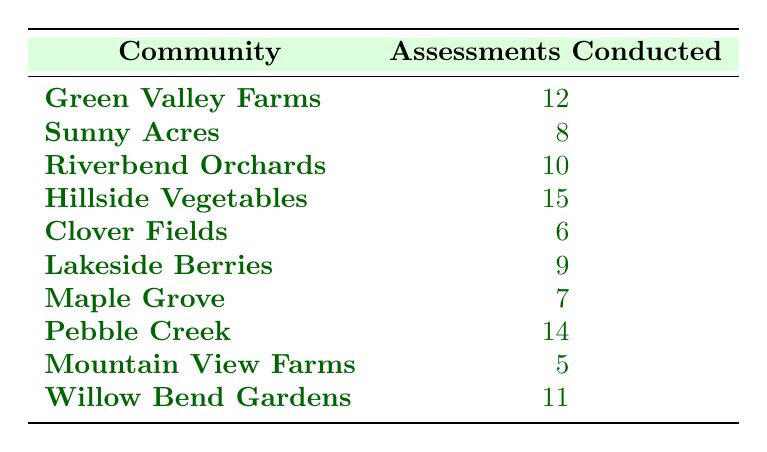What is the community with the highest number of assessments conducted? The values in the "Assessments Conducted" column are compared to determine the highest. Hillside Vegetables has 15 assessments, which is greater than any other community in the table.
Answer: Hillside Vegetables Which community conducted the least number of assessments? By examining the "Assessments Conducted" values, Mountain View Farms is identified with the lowest count of 5 assessments.
Answer: Mountain View Farms How many total assessments were conducted across all communities? Adding the assessments: 12 + 8 + 10 + 15 + 6 + 9 + 7 + 14 + 5 + 11 = 87. Thus, the total count of assessments conducted is 87.
Answer: 87 What is the average number of assessments conducted for these communities? There are 10 communities. The total number of assessments is 87. To find the average, we divide the total by the number of communities: 87/10 = 8.7.
Answer: 8.7 Is it true that more than 10 assessments were conducted in at least half of the communities? There are 10 communities, and 6 of them (Hillside Vegetables, Pebble Creek, Green Valley Farms, Riverbend Orchards, Willow Bend Gardens, Lakeside Berries) have more than 10 assessments, which is indeed more than half.
Answer: Yes How many communities conducted between 6 and 10 assessments? Communities with 6 to 10 assessments are Clover Fields (6), Lakeside Berries (9), Maple Grove (7), and Riverbend Orchards (10). Counting these gives us 4 communities in this range.
Answer: 4 Which community has a number of assessments that is 2 less than the average? From the previous calculation, the average is 8.7; therefore, we look for communities with 6.7 or rounded to 7 assessments. Maple Grove fits this criteria, as it conducted 7 assessments.
Answer: Maple Grove What is the difference between the highest and lowest number of assessments conducted? The highest is 15 (Hillside Vegetables) and the lowest is 5 (Mountain View Farms). The difference is calculated as 15 - 5 = 10.
Answer: 10 Are there more communities with over 12 assessments conducted than under 7? Communities with over 12 assessments are Hillside Vegetables (15), Pebble Creek (14), and Green Valley Farms (12), totaling 3. Communities with under 7 assessments: Mountain View Farms (5) and Clover Fields (6) total 2. Since 3 is more than 2, the statement is true.
Answer: Yes 